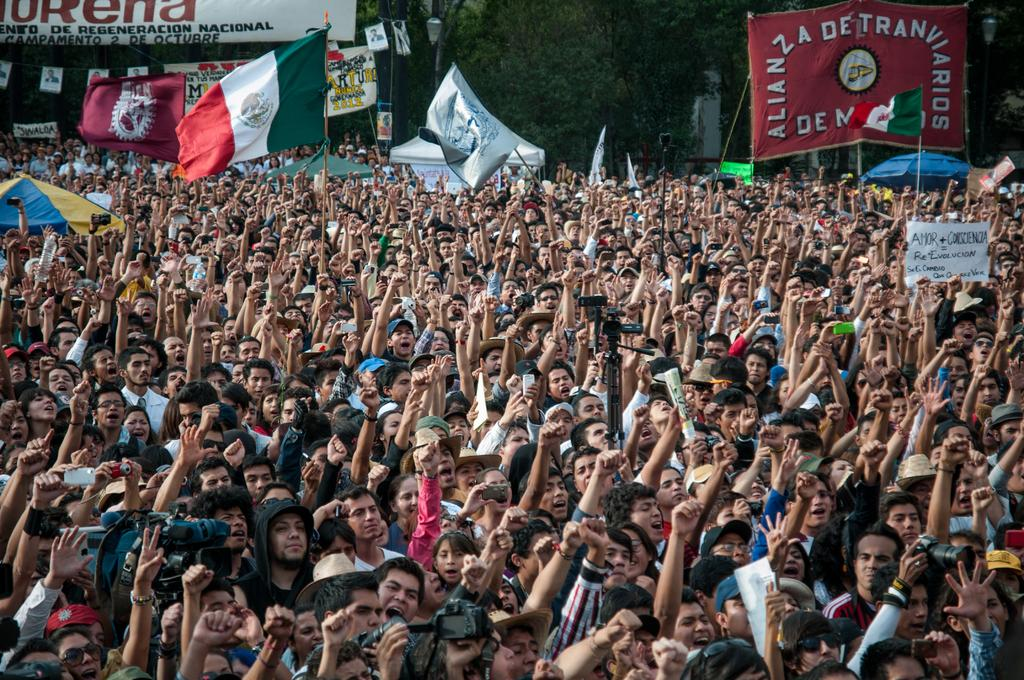What is the main subject of the image? The main subject of the image is a huge crowd. What are the people in the crowd doing? The people in the crowd are raising their hands up. What can be seen besides the crowd in the image? There are flags and a big banner in the background of the image. What is visible behind the banner in the image? Trees are visible behind the banner. How many snails can be seen crawling on the banner in the image? There are no snails present in the image; the focus is on the crowd, flags, and banner. 